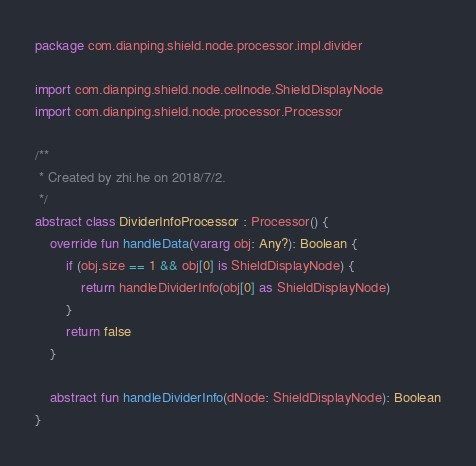Convert code to text. <code><loc_0><loc_0><loc_500><loc_500><_Kotlin_>package com.dianping.shield.node.processor.impl.divider

import com.dianping.shield.node.cellnode.ShieldDisplayNode
import com.dianping.shield.node.processor.Processor

/**
 * Created by zhi.he on 2018/7/2.
 */
abstract class DividerInfoProcessor : Processor() {
    override fun handleData(vararg obj: Any?): Boolean {
        if (obj.size == 1 && obj[0] is ShieldDisplayNode) {
            return handleDividerInfo(obj[0] as ShieldDisplayNode)
        }
        return false
    }

    abstract fun handleDividerInfo(dNode: ShieldDisplayNode): Boolean
}</code> 